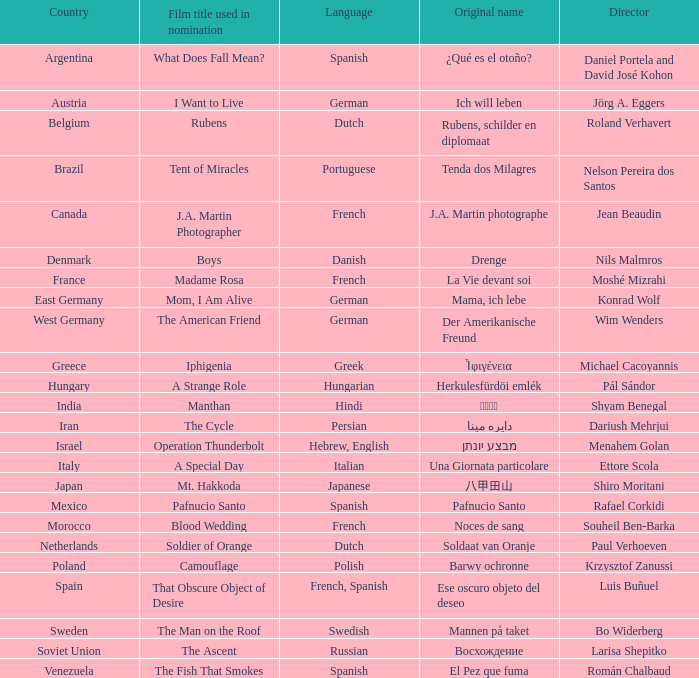Which country is the director Roland Verhavert from? Belgium. 